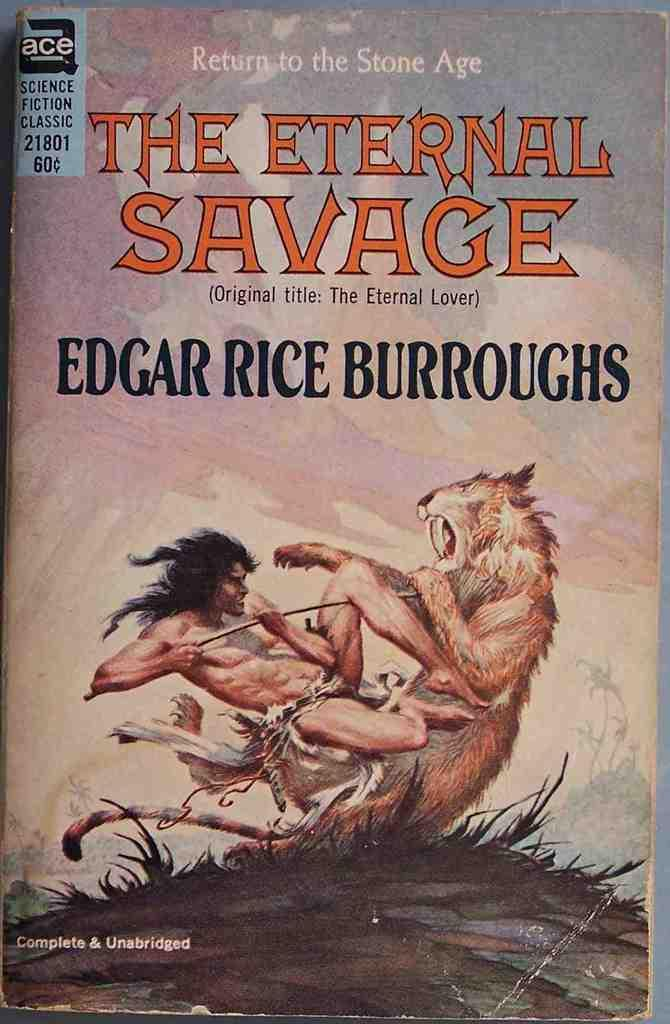<image>
Create a compact narrative representing the image presented. The books is written by the author Edgar Rice Burroughs. 